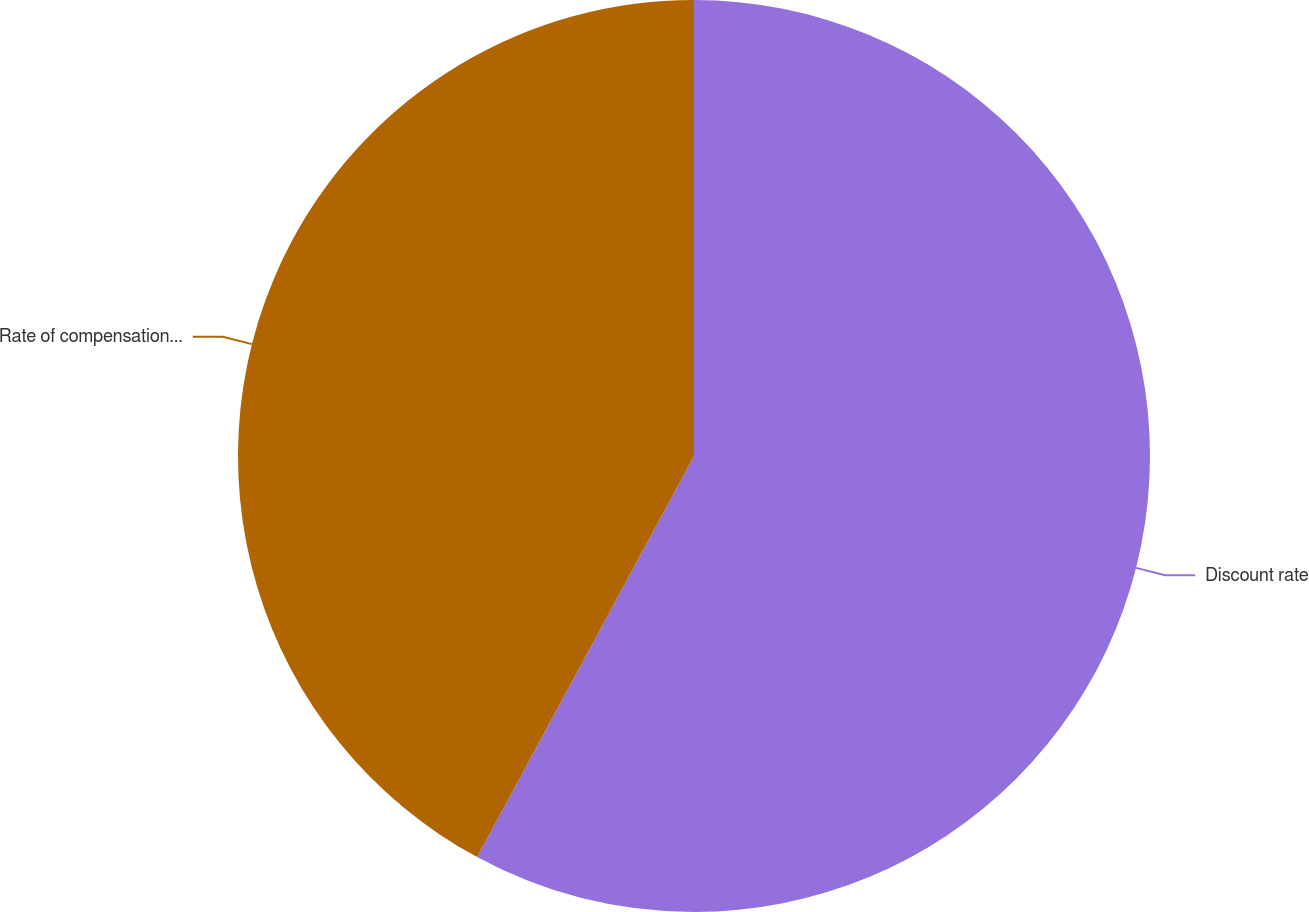<chart> <loc_0><loc_0><loc_500><loc_500><pie_chart><fcel>Discount rate<fcel>Rate of compensation increase<nl><fcel>57.89%<fcel>42.11%<nl></chart> 